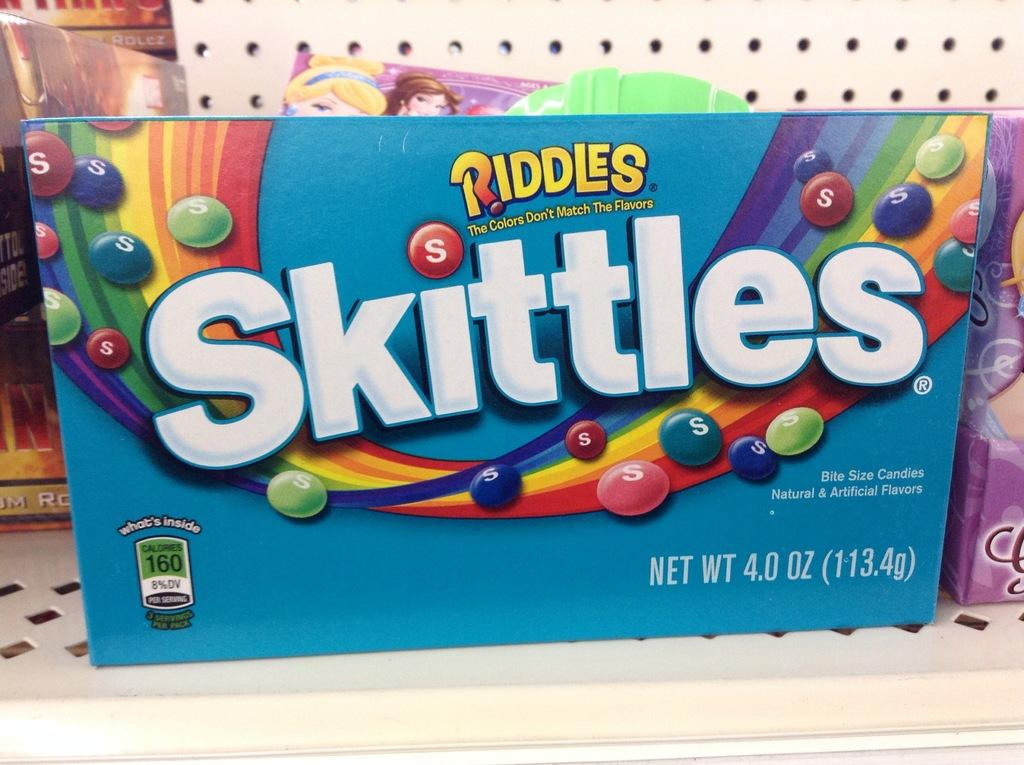What object can be seen in the image? There is a box in the image. What is written or printed on the box? There is text on the box. How many boats are visible in the image? There are no boats present in the image. What type of comb is used by the person in the image? There is no person or comb present in the image. 